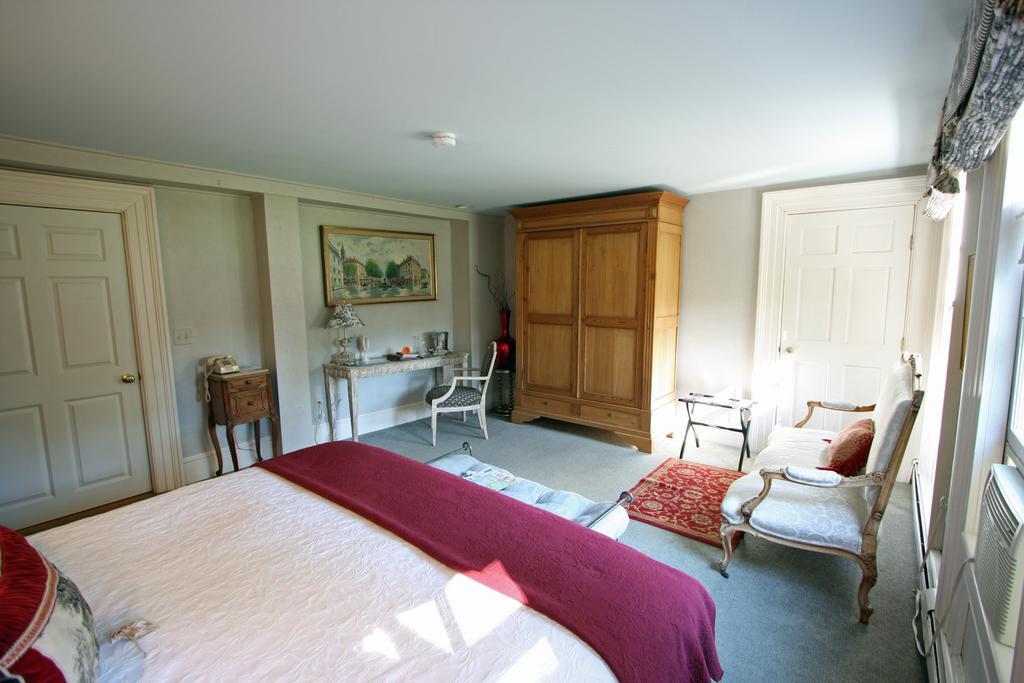In one or two sentences, can you explain what this image depicts? In this picture I can see a bed which has pillow and blanket. Here I can see chairs, tables and a sofa. I can also see doors and photo on the wall. 